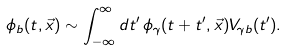Convert formula to latex. <formula><loc_0><loc_0><loc_500><loc_500>\phi _ { b } ( t , \vec { x } ) \sim \int _ { - \infty } ^ { \infty } d t ^ { \prime } \, \phi _ { \gamma } ( t + t ^ { \prime } , \vec { x } ) V _ { \gamma b } ( t ^ { \prime } ) .</formula> 